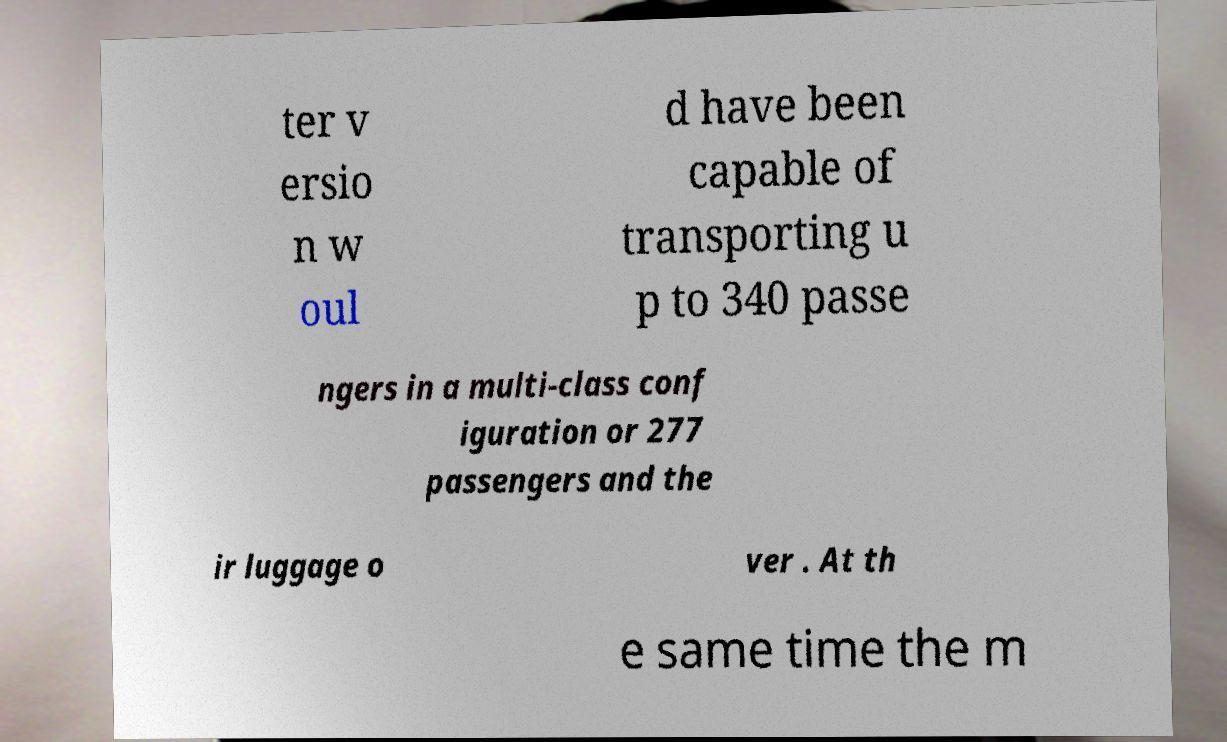I need the written content from this picture converted into text. Can you do that? ter v ersio n w oul d have been capable of transporting u p to 340 passe ngers in a multi-class conf iguration or 277 passengers and the ir luggage o ver . At th e same time the m 